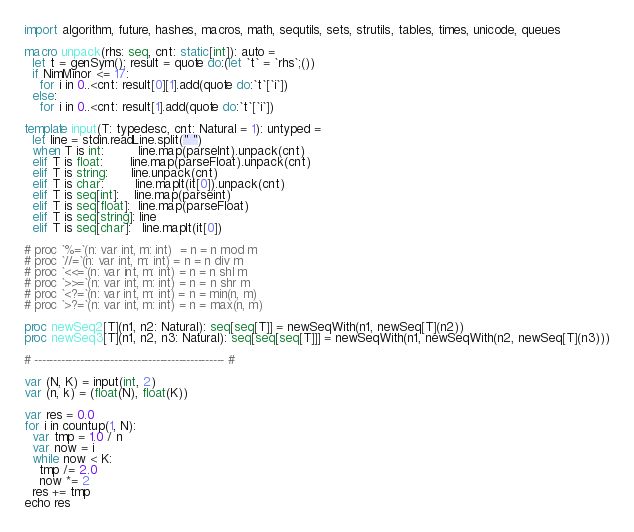<code> <loc_0><loc_0><loc_500><loc_500><_Nim_>import algorithm, future, hashes, macros, math, sequtils, sets, strutils, tables, times, unicode, queues

macro unpack(rhs: seq, cnt: static[int]): auto =
  let t = genSym(); result = quote do:(let `t` = `rhs`;())
  if NimMinor <= 17:
    for i in 0..<cnt: result[0][1].add(quote do:`t`[`i`])
  else:
    for i in 0..<cnt: result[1].add(quote do:`t`[`i`])

template input(T: typedesc, cnt: Natural = 1): untyped =
  let line = stdin.readLine.split(" ")
  when T is int:         line.map(parseInt).unpack(cnt)
  elif T is float:       line.map(parseFloat).unpack(cnt)
  elif T is string:      line.unpack(cnt)
  elif T is char:        line.mapIt(it[0]).unpack(cnt)
  elif T is seq[int]:    line.map(parseint)
  elif T is seq[float]:  line.map(parseFloat)
  elif T is seq[string]: line
  elif T is seq[char]:   line.mapIt(it[0])

# proc `%=`(n: var int, m: int)  = n = n mod m
# proc `//=`(n: var int, m: int) = n = n div m
# proc `<<=`(n: var int, m: int) = n = n shl m
# proc `>>=`(n: var int, m: int) = n = n shr m
# proc `<?=`(n: var int, m: int) = n = min(n, m)
# proc `>?=`(n: var int, m: int) = n = max(n, m)

proc newSeq2[T](n1, n2: Natural): seq[seq[T]] = newSeqWith(n1, newSeq[T](n2))
proc newSeq3[T](n1, n2, n3: Natural): seq[seq[seq[T]]] = newSeqWith(n1, newSeqWith(n2, newSeq[T](n3)))

# -------------------------------------------------- #

var (N, K) = input(int, 2)
var (n, k) = (float(N), float(K))

var res = 0.0
for i in countup(1, N):
  var tmp = 1.0 / n
  var now = i
  while now < K:
    tmp /= 2.0
    now *= 2
  res += tmp
echo res</code> 